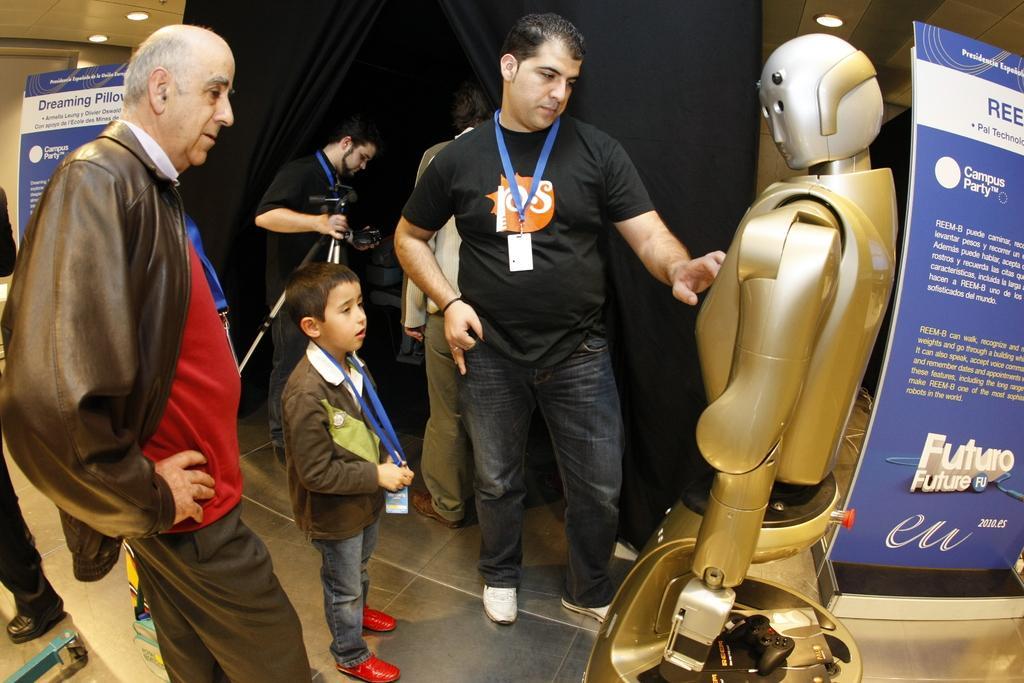Please provide a concise description of this image. In this image we can see some group of persons standing near the robot and in the background of the image there is a person holding camera in his hands and there is a black color curtain and there are some posters which are in blue color. 